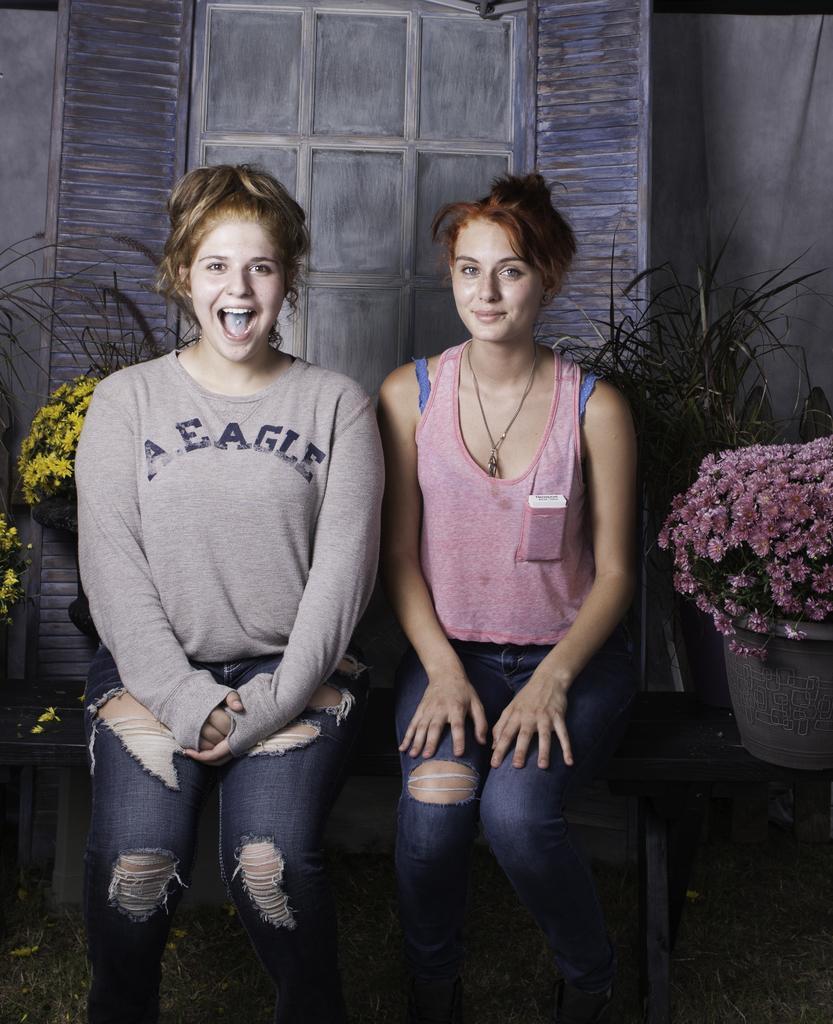Please provide a concise description of this image. In this image we can see two women are sitting on a bench. Here we can see plants and flowers. In the background we can see wall and window doors. 